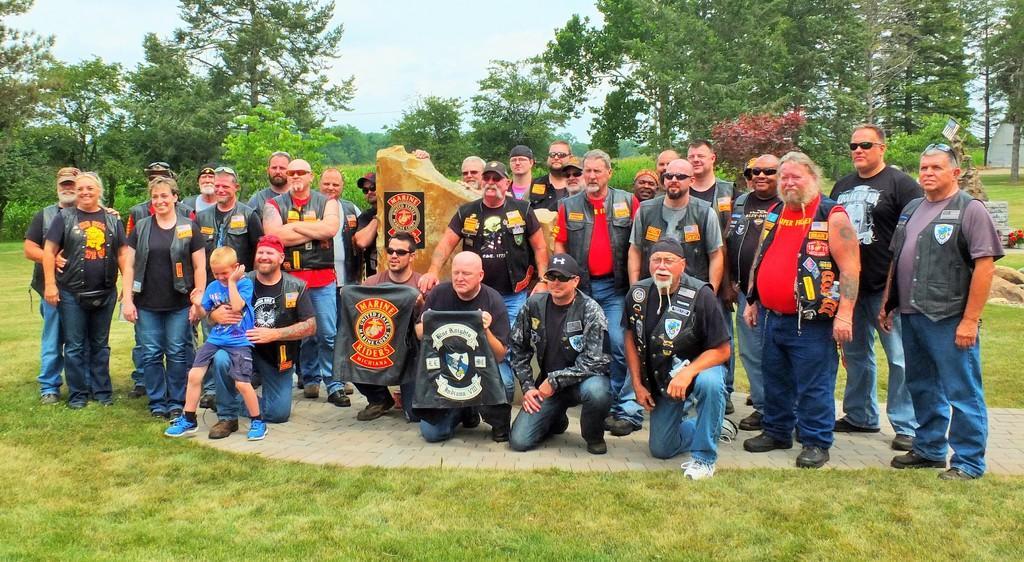Describe this image in one or two sentences. In this image we can see some group of persons standing and some are crouching and in the background of the image there are some trees and clear sky. 